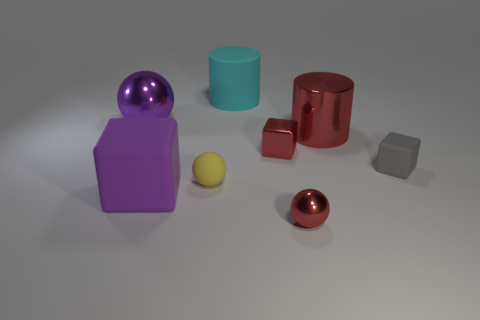Add 2 blue blocks. How many objects exist? 10 Subtract all blocks. How many objects are left? 5 Subtract 1 red cubes. How many objects are left? 7 Subtract all gray rubber cubes. Subtract all small yellow rubber spheres. How many objects are left? 6 Add 2 large cyan matte cylinders. How many large cyan matte cylinders are left? 3 Add 4 big green metallic cylinders. How many big green metallic cylinders exist? 4 